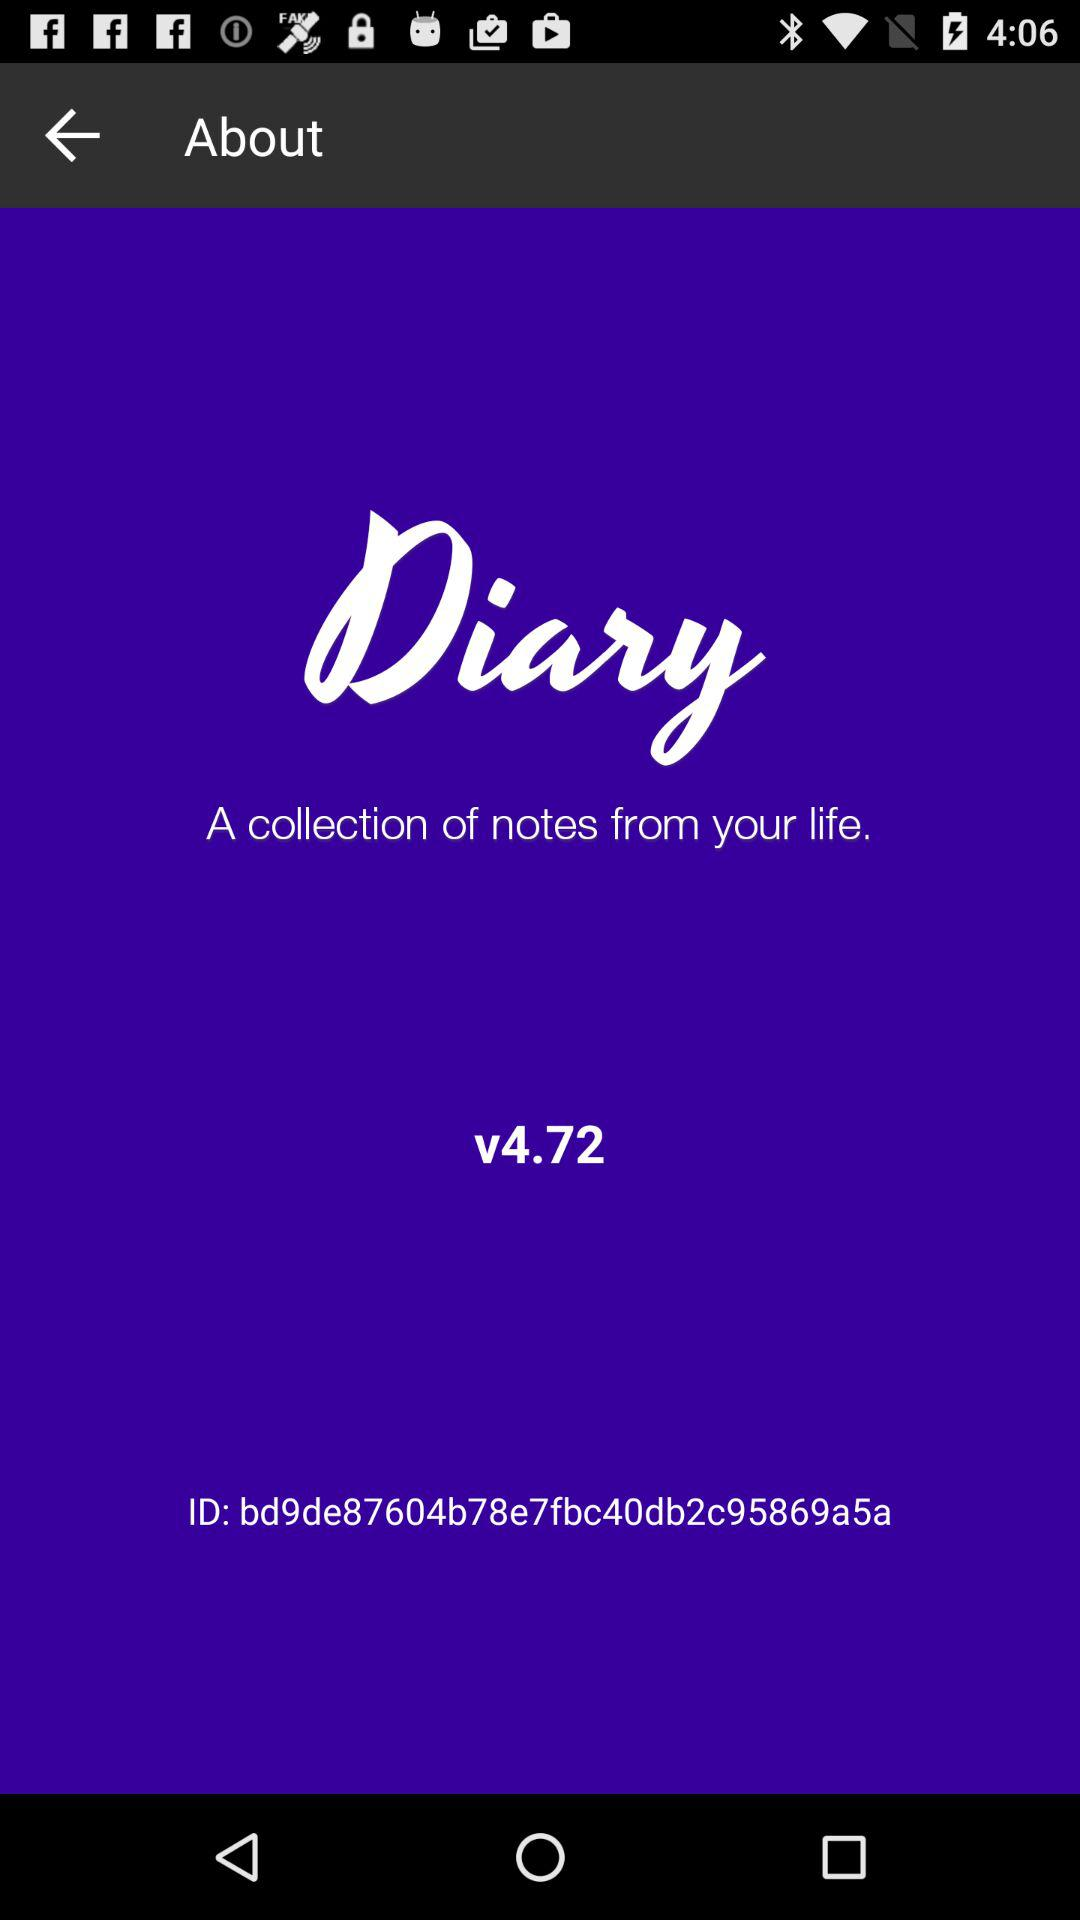What is the version of the application? The version of the application is v4.72. 